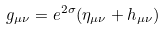Convert formula to latex. <formula><loc_0><loc_0><loc_500><loc_500>g _ { \mu \nu } = e ^ { 2 \sigma } ( \eta _ { \mu \nu } + h _ { \mu \nu } )</formula> 